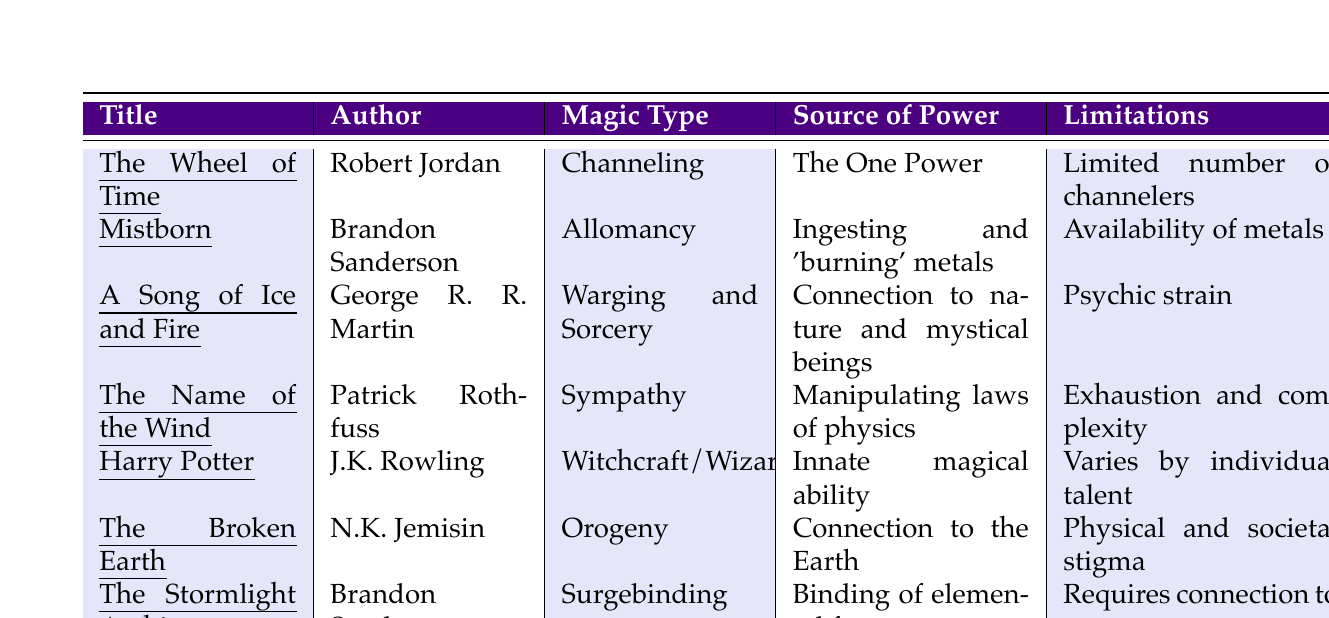What is the magic type for "The Name of the Wind"? In the table, we look under the "Magic Type" column for the title "The Name of the Wind." The entry shows that the magic type is "Sympathy."
Answer: Sympathy Who is the author of "Mistborn"? We can locate "Mistborn" in the table, and under the "Author" column, the corresponding author is "Brandon Sanderson."
Answer: Brandon Sanderson What is a limitation for the magic system in "Harry Potter"? By examining the "Limitations" column for "Harry Potter," it states that the limitations vary by individual talent.
Answer: Varies by individual talent How many magic systems listed involve a connection to a natural element? We find "A Song of Ice and Fire" and "The Broken Earth" both mention a connection to nature, while "Orogeny" involves connection to the Earth. Thus there are three systems.
Answer: Three Is "Allomancy" a magic type in "A Song of Ice and Fire"? Looking at the table, "Allomancy" is listed under "Mistborn" and not "A Song of Ice and Fire," which has "Warging and Sorcery" as its magic type. Thus, the statement is false.
Answer: No What is the source of power for "The Wheel of Time"? Referring to the "Source of Power" column, we find that "The Wheel of Time" derives its power from "The One Power (male and female halves: saidin and saidar)."
Answer: The One Power (male and female halves: saidin and saidar) Which magic system has "requires education and practice" as a limitation? In the "Limitations" column for "Harry Potter," it explicitly states that it requires education and practice to control the magic system effectively.
Answer: Harry Potter What is a common theme in the limitations of the magic systems? Upon reviewing the limitations, a common theme is the necessity of emotional control or proper understanding, present in "The Wheel of Time," "The Name of the Wind," and "The Stormlight Archive."
Answer: Emotional control and understanding Among the listed magic systems, which one is related to political and social restrictions? The limitations in "The Wheel of Time" mention political and social restrictions, indicating its influence over the magic system's usage.
Answer: The Wheel of Time How does the source of power differ between "Harry Potter" and "Mistborn"? "Harry Potter" derives power from innate ability and wands, while "Mistborn" requires ingestion and burning of metals. The differing sources highlight varying mechanisms of accessing magic.
Answer: Different mechanisms: innate ability vs. ingestion of metals 